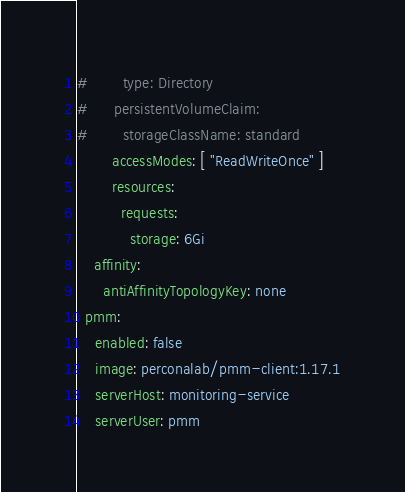Convert code to text. <code><loc_0><loc_0><loc_500><loc_500><_YAML_>#        type: Directory
#      persistentVolumeClaim:
#        storageClassName: standard
        accessModes: [ "ReadWriteOnce" ]
        resources:
          requests:
            storage: 6Gi
    affinity:
      antiAffinityTopologyKey: none
  pmm:
    enabled: false
    image: perconalab/pmm-client:1.17.1
    serverHost: monitoring-service
    serverUser: pmm
</code> 